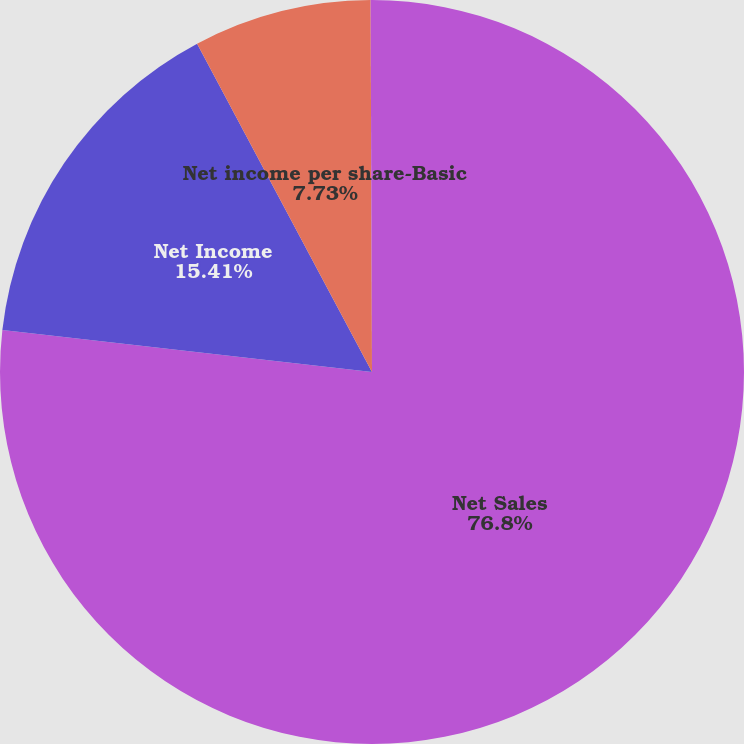Convert chart. <chart><loc_0><loc_0><loc_500><loc_500><pie_chart><fcel>Net Sales<fcel>Net Income<fcel>Net income per share-Basic<fcel>Net income per share-Diluted<nl><fcel>76.8%<fcel>15.41%<fcel>7.73%<fcel>0.06%<nl></chart> 